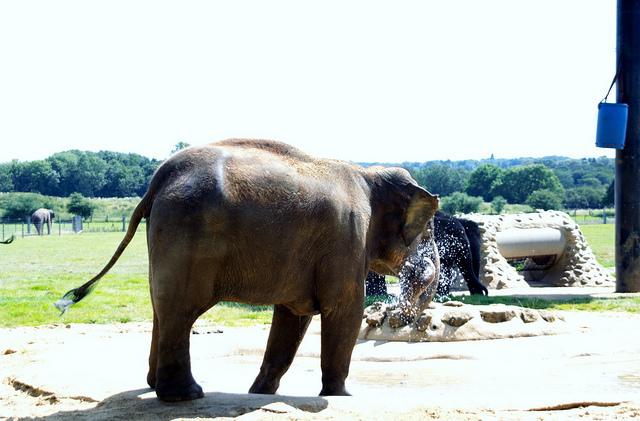Is this the elephants mother?
Short answer required. No. Is the elephant drinking?
Write a very short answer. Yes. What animal is this?
Give a very brief answer. Elephant. Is the elephant playing?
Be succinct. Yes. What color is the bucket?
Short answer required. Blue. 